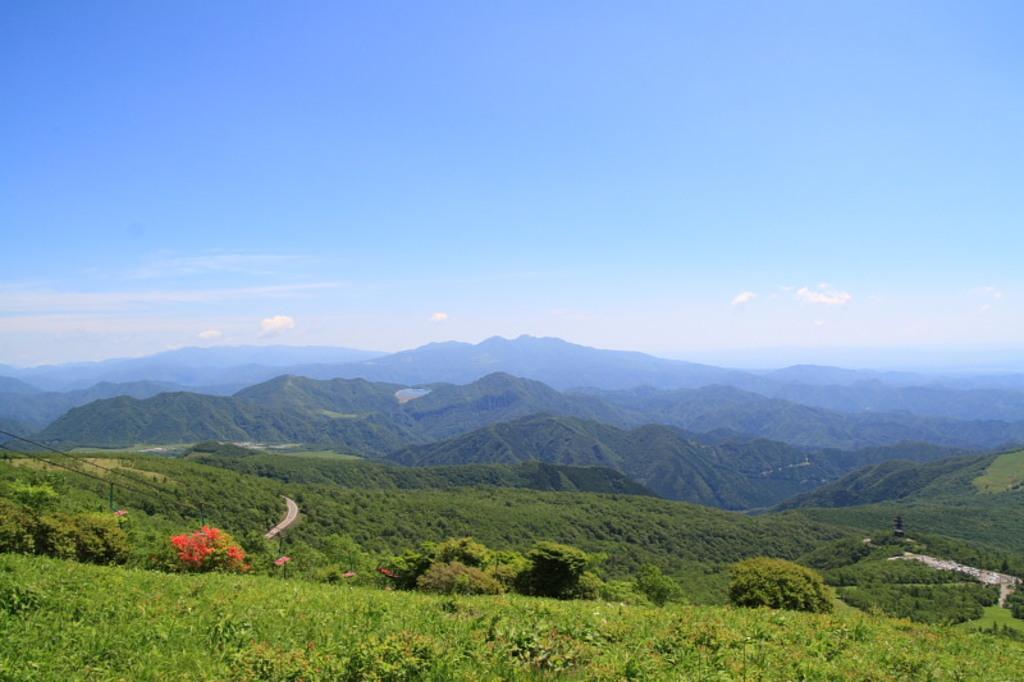How would you summarize this image in a sentence or two? On the bottom we can see farmland. Here we can see road and some electrical wires. On the background we can see many mountains. On the right we can see plants, trees and grass. On the top we can see sky and clouds. 